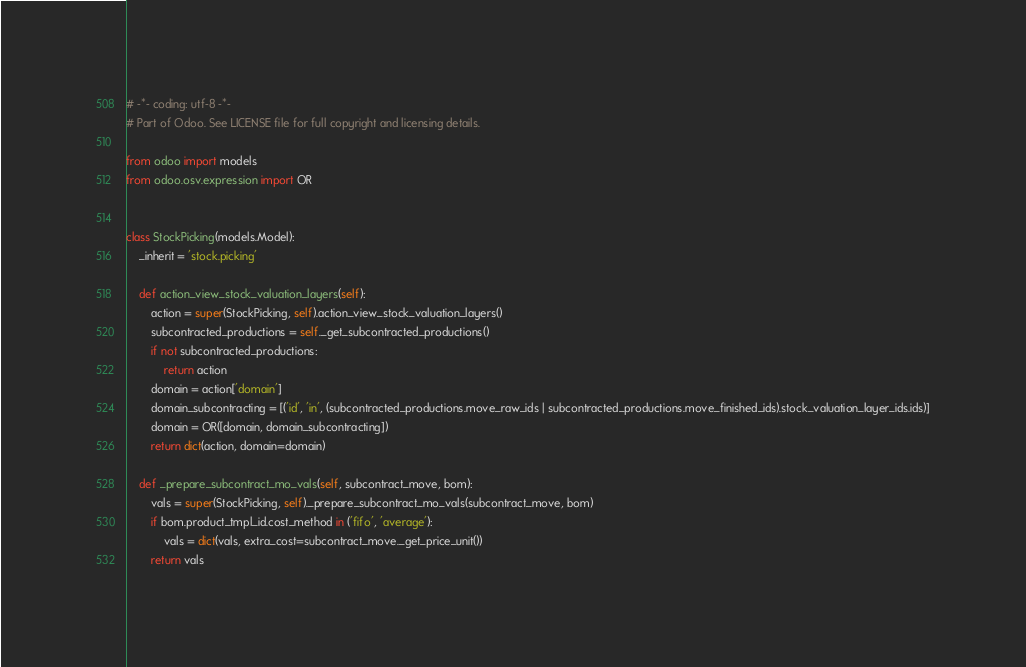Convert code to text. <code><loc_0><loc_0><loc_500><loc_500><_Python_># -*- coding: utf-8 -*-
# Part of Odoo. See LICENSE file for full copyright and licensing details.

from odoo import models
from odoo.osv.expression import OR


class StockPicking(models.Model):
    _inherit = 'stock.picking'

    def action_view_stock_valuation_layers(self):
        action = super(StockPicking, self).action_view_stock_valuation_layers()
        subcontracted_productions = self._get_subcontracted_productions()
        if not subcontracted_productions:
            return action
        domain = action['domain']
        domain_subcontracting = [('id', 'in', (subcontracted_productions.move_raw_ids | subcontracted_productions.move_finished_ids).stock_valuation_layer_ids.ids)]
        domain = OR([domain, domain_subcontracting])
        return dict(action, domain=domain)

    def _prepare_subcontract_mo_vals(self, subcontract_move, bom):
        vals = super(StockPicking, self)._prepare_subcontract_mo_vals(subcontract_move, bom)
        if bom.product_tmpl_id.cost_method in ('fifo', 'average'):
            vals = dict(vals, extra_cost=subcontract_move._get_price_unit())
        return vals
</code> 